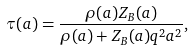<formula> <loc_0><loc_0><loc_500><loc_500>\tau ( a ) = \frac { \rho ( a ) Z _ { B } ( a ) } { \rho ( a ) + Z _ { B } ( a ) q ^ { 2 } a ^ { 2 } } ,</formula> 